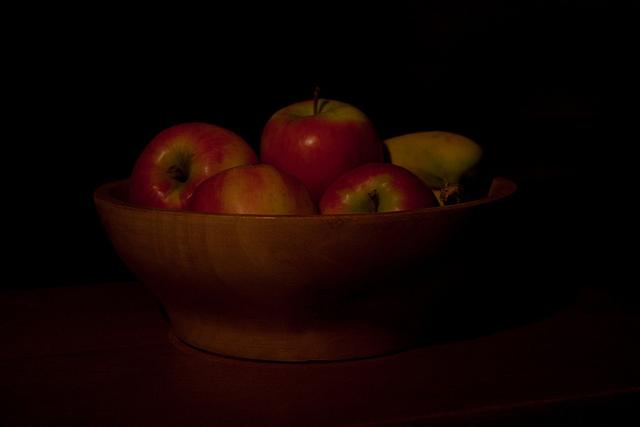What color is the bowl?
Be succinct. Brown. Is it sunny or a little shady?
Short answer required. Shady. Is that real fruit?
Be succinct. Yes. Is this art?
Answer briefly. No. Could you eat the entire fruit on the counter?
Answer briefly. Yes. What utensil is resting in the bowl?
Give a very brief answer. None. Why would someone not like the fruit at the front?
Write a very short answer. Spoiled. How many different colors are in this picture?
Short answer required. 4. Are all of these fruits grown in the same regions?
Give a very brief answer. Yes. Are these tangelos?
Keep it brief. No. What image does the arrangement of fruit form?
Concise answer only. Circle. What fruits are shown?
Give a very brief answer. Apples. What fruit is in the bowl?
Concise answer only. Apples. What fruit is shown?
Keep it brief. Apples. What must people do before they may eat this fruit?
Keep it brief. Wash it. What color are the fruit?
Short answer required. Red. How many types of fruit are in the bowl?
Write a very short answer. 2. What kind of fruit is this?
Be succinct. Apple. How many apples are in the picture?
Concise answer only. 5. Was ceramic glaze or acrylic paint used to decorate these objects?
Be succinct. Glaze. How many different fruits are in the bowl?
Concise answer only. 2. What is the orange fruit?
Answer briefly. Apple. Is there a light above the fruits?
Keep it brief. No. What is on display?
Answer briefly. Apples. What fruit is this?
Be succinct. Apple. What types of apples are shown?
Quick response, please. Red. How many of these do you usually peel before eating?
Short answer required. 1. Does the fruit look like it has freckles?
Write a very short answer. No. Are the apples clean?
Quick response, please. Yes. Is there an orange in the picture?
Quick response, please. No. How many different foods are on the table?
Be succinct. 2. Are the flowers real or fake?
Be succinct. Real. What fruit is on the left?
Short answer required. Apple. Which piece of fruit would you like to eat?
Give a very brief answer. Apple. What is the fruit in?
Keep it brief. Bowl. What color is the fruits?
Quick response, please. Red. What color is the fruit?
Be succinct. Red. What fruits are in the photo?
Give a very brief answer. Apples. Are the apples store bought?
Be succinct. Yes. What fruit can be seen?
Write a very short answer. Apple. What is in the bowl?
Quick response, please. Apples. What is the point of this art?
Short answer required. Still life. What color is the apple?
Be succinct. Red. What kind of food is this?
Be succinct. Apple. What color is the fruit in the bowl?
Answer briefly. Red. What food is this?
Short answer required. Apples. What is on the table?
Quick response, please. Apples. How many types of fruit are there in the image?
Concise answer only. 2. Are these tangerines?
Give a very brief answer. No. What object is this?
Keep it brief. Bowl. How many different fruits can be seen?
Quick response, please. 2. What type of fruit is this?
Quick response, please. Apple. What color is the bowl containing the fruit?
Quick response, please. Brown. Is there a large color contrast in this picture?
Quick response, please. No. What is this?
Write a very short answer. Apples. What color is the paint smudge to the left of the main object in the picture:?
Be succinct. Black. What is the color of the fruit in the bowl?
Answer briefly. Red. Where did they get these apples?
Write a very short answer. Store. Are the fruits peeled?
Short answer required. No. What kind of apples are these?
Be succinct. Honeycrisp. Is the fruit on a plate?
Give a very brief answer. No. Are there papais on the table?
Short answer required. No. Is there an orange in the image?
Answer briefly. No. Why are the fruits on display?
Write a very short answer. Apples. 